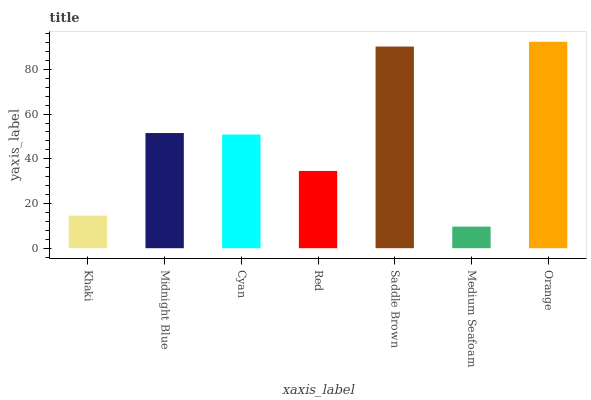Is Medium Seafoam the minimum?
Answer yes or no. Yes. Is Orange the maximum?
Answer yes or no. Yes. Is Midnight Blue the minimum?
Answer yes or no. No. Is Midnight Blue the maximum?
Answer yes or no. No. Is Midnight Blue greater than Khaki?
Answer yes or no. Yes. Is Khaki less than Midnight Blue?
Answer yes or no. Yes. Is Khaki greater than Midnight Blue?
Answer yes or no. No. Is Midnight Blue less than Khaki?
Answer yes or no. No. Is Cyan the high median?
Answer yes or no. Yes. Is Cyan the low median?
Answer yes or no. Yes. Is Red the high median?
Answer yes or no. No. Is Khaki the low median?
Answer yes or no. No. 